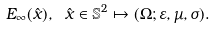Convert formula to latex. <formula><loc_0><loc_0><loc_500><loc_500>E _ { \infty } ( \hat { x } ) , \ \hat { x } \in \mathbb { S } ^ { 2 } \mapsto ( \Omega ; \varepsilon , \mu , \sigma ) .</formula> 